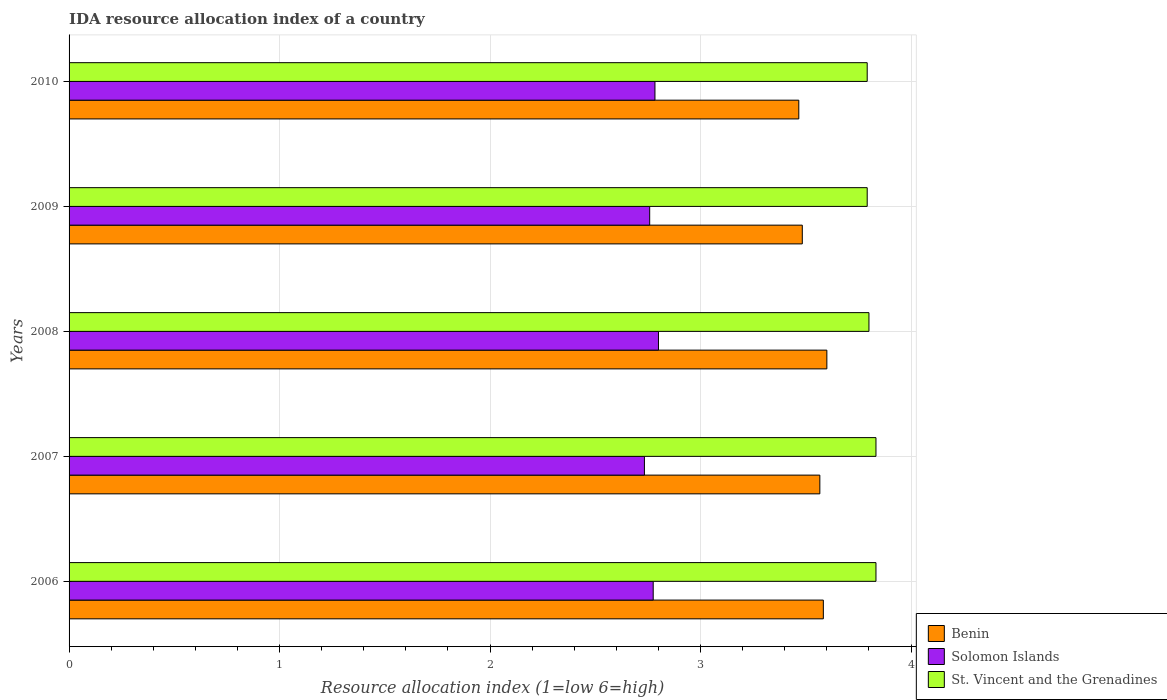How many different coloured bars are there?
Your answer should be very brief. 3. In how many cases, is the number of bars for a given year not equal to the number of legend labels?
Provide a succinct answer. 0. What is the IDA resource allocation index in Benin in 2007?
Make the answer very short. 3.57. Across all years, what is the maximum IDA resource allocation index in St. Vincent and the Grenadines?
Your response must be concise. 3.83. Across all years, what is the minimum IDA resource allocation index in Benin?
Ensure brevity in your answer.  3.47. In which year was the IDA resource allocation index in St. Vincent and the Grenadines maximum?
Provide a succinct answer. 2006. What is the total IDA resource allocation index in St. Vincent and the Grenadines in the graph?
Provide a short and direct response. 19.05. What is the difference between the IDA resource allocation index in Benin in 2010 and the IDA resource allocation index in St. Vincent and the Grenadines in 2007?
Provide a short and direct response. -0.37. What is the average IDA resource allocation index in St. Vincent and the Grenadines per year?
Provide a short and direct response. 3.81. In the year 2010, what is the difference between the IDA resource allocation index in Solomon Islands and IDA resource allocation index in Benin?
Keep it short and to the point. -0.68. In how many years, is the IDA resource allocation index in Solomon Islands greater than 3 ?
Your answer should be very brief. 0. What is the ratio of the IDA resource allocation index in Solomon Islands in 2008 to that in 2009?
Ensure brevity in your answer.  1.02. Is the IDA resource allocation index in St. Vincent and the Grenadines in 2007 less than that in 2009?
Keep it short and to the point. No. Is the difference between the IDA resource allocation index in Solomon Islands in 2006 and 2008 greater than the difference between the IDA resource allocation index in Benin in 2006 and 2008?
Provide a short and direct response. No. What is the difference between the highest and the second highest IDA resource allocation index in Solomon Islands?
Provide a succinct answer. 0.02. What is the difference between the highest and the lowest IDA resource allocation index in St. Vincent and the Grenadines?
Ensure brevity in your answer.  0.04. Is the sum of the IDA resource allocation index in Benin in 2009 and 2010 greater than the maximum IDA resource allocation index in Solomon Islands across all years?
Give a very brief answer. Yes. What does the 1st bar from the top in 2006 represents?
Offer a very short reply. St. Vincent and the Grenadines. What does the 2nd bar from the bottom in 2010 represents?
Keep it short and to the point. Solomon Islands. How many years are there in the graph?
Offer a very short reply. 5. What is the difference between two consecutive major ticks on the X-axis?
Make the answer very short. 1. Are the values on the major ticks of X-axis written in scientific E-notation?
Your answer should be very brief. No. Where does the legend appear in the graph?
Make the answer very short. Bottom right. How many legend labels are there?
Offer a very short reply. 3. What is the title of the graph?
Make the answer very short. IDA resource allocation index of a country. Does "Bangladesh" appear as one of the legend labels in the graph?
Your response must be concise. No. What is the label or title of the X-axis?
Provide a succinct answer. Resource allocation index (1=low 6=high). What is the label or title of the Y-axis?
Ensure brevity in your answer.  Years. What is the Resource allocation index (1=low 6=high) in Benin in 2006?
Offer a very short reply. 3.58. What is the Resource allocation index (1=low 6=high) of Solomon Islands in 2006?
Ensure brevity in your answer.  2.77. What is the Resource allocation index (1=low 6=high) in St. Vincent and the Grenadines in 2006?
Keep it short and to the point. 3.83. What is the Resource allocation index (1=low 6=high) in Benin in 2007?
Offer a very short reply. 3.57. What is the Resource allocation index (1=low 6=high) of Solomon Islands in 2007?
Make the answer very short. 2.73. What is the Resource allocation index (1=low 6=high) in St. Vincent and the Grenadines in 2007?
Your answer should be very brief. 3.83. What is the Resource allocation index (1=low 6=high) of Benin in 2008?
Ensure brevity in your answer.  3.6. What is the Resource allocation index (1=low 6=high) in St. Vincent and the Grenadines in 2008?
Give a very brief answer. 3.8. What is the Resource allocation index (1=low 6=high) of Benin in 2009?
Your answer should be very brief. 3.48. What is the Resource allocation index (1=low 6=high) of Solomon Islands in 2009?
Keep it short and to the point. 2.76. What is the Resource allocation index (1=low 6=high) of St. Vincent and the Grenadines in 2009?
Your answer should be very brief. 3.79. What is the Resource allocation index (1=low 6=high) of Benin in 2010?
Provide a short and direct response. 3.47. What is the Resource allocation index (1=low 6=high) of Solomon Islands in 2010?
Make the answer very short. 2.78. What is the Resource allocation index (1=low 6=high) of St. Vincent and the Grenadines in 2010?
Your answer should be compact. 3.79. Across all years, what is the maximum Resource allocation index (1=low 6=high) in St. Vincent and the Grenadines?
Ensure brevity in your answer.  3.83. Across all years, what is the minimum Resource allocation index (1=low 6=high) of Benin?
Ensure brevity in your answer.  3.47. Across all years, what is the minimum Resource allocation index (1=low 6=high) of Solomon Islands?
Ensure brevity in your answer.  2.73. Across all years, what is the minimum Resource allocation index (1=low 6=high) of St. Vincent and the Grenadines?
Offer a very short reply. 3.79. What is the total Resource allocation index (1=low 6=high) of Solomon Islands in the graph?
Keep it short and to the point. 13.85. What is the total Resource allocation index (1=low 6=high) in St. Vincent and the Grenadines in the graph?
Your response must be concise. 19.05. What is the difference between the Resource allocation index (1=low 6=high) of Benin in 2006 and that in 2007?
Make the answer very short. 0.02. What is the difference between the Resource allocation index (1=low 6=high) of Solomon Islands in 2006 and that in 2007?
Give a very brief answer. 0.04. What is the difference between the Resource allocation index (1=low 6=high) in Benin in 2006 and that in 2008?
Keep it short and to the point. -0.02. What is the difference between the Resource allocation index (1=low 6=high) in Solomon Islands in 2006 and that in 2008?
Provide a succinct answer. -0.03. What is the difference between the Resource allocation index (1=low 6=high) in Solomon Islands in 2006 and that in 2009?
Offer a very short reply. 0.02. What is the difference between the Resource allocation index (1=low 6=high) of St. Vincent and the Grenadines in 2006 and that in 2009?
Offer a terse response. 0.04. What is the difference between the Resource allocation index (1=low 6=high) of Benin in 2006 and that in 2010?
Ensure brevity in your answer.  0.12. What is the difference between the Resource allocation index (1=low 6=high) of Solomon Islands in 2006 and that in 2010?
Your response must be concise. -0.01. What is the difference between the Resource allocation index (1=low 6=high) of St. Vincent and the Grenadines in 2006 and that in 2010?
Offer a very short reply. 0.04. What is the difference between the Resource allocation index (1=low 6=high) of Benin in 2007 and that in 2008?
Offer a terse response. -0.03. What is the difference between the Resource allocation index (1=low 6=high) in Solomon Islands in 2007 and that in 2008?
Your response must be concise. -0.07. What is the difference between the Resource allocation index (1=low 6=high) of St. Vincent and the Grenadines in 2007 and that in 2008?
Give a very brief answer. 0.03. What is the difference between the Resource allocation index (1=low 6=high) of Benin in 2007 and that in 2009?
Your answer should be compact. 0.08. What is the difference between the Resource allocation index (1=low 6=high) of Solomon Islands in 2007 and that in 2009?
Your answer should be very brief. -0.03. What is the difference between the Resource allocation index (1=low 6=high) in St. Vincent and the Grenadines in 2007 and that in 2009?
Your answer should be compact. 0.04. What is the difference between the Resource allocation index (1=low 6=high) in Solomon Islands in 2007 and that in 2010?
Offer a very short reply. -0.05. What is the difference between the Resource allocation index (1=low 6=high) in St. Vincent and the Grenadines in 2007 and that in 2010?
Keep it short and to the point. 0.04. What is the difference between the Resource allocation index (1=low 6=high) of Benin in 2008 and that in 2009?
Your response must be concise. 0.12. What is the difference between the Resource allocation index (1=low 6=high) in Solomon Islands in 2008 and that in 2009?
Your answer should be very brief. 0.04. What is the difference between the Resource allocation index (1=low 6=high) of St. Vincent and the Grenadines in 2008 and that in 2009?
Keep it short and to the point. 0.01. What is the difference between the Resource allocation index (1=low 6=high) in Benin in 2008 and that in 2010?
Offer a very short reply. 0.13. What is the difference between the Resource allocation index (1=low 6=high) of Solomon Islands in 2008 and that in 2010?
Ensure brevity in your answer.  0.02. What is the difference between the Resource allocation index (1=low 6=high) of St. Vincent and the Grenadines in 2008 and that in 2010?
Keep it short and to the point. 0.01. What is the difference between the Resource allocation index (1=low 6=high) in Benin in 2009 and that in 2010?
Give a very brief answer. 0.02. What is the difference between the Resource allocation index (1=low 6=high) in Solomon Islands in 2009 and that in 2010?
Your answer should be compact. -0.03. What is the difference between the Resource allocation index (1=low 6=high) of Benin in 2006 and the Resource allocation index (1=low 6=high) of Solomon Islands in 2007?
Ensure brevity in your answer.  0.85. What is the difference between the Resource allocation index (1=low 6=high) of Benin in 2006 and the Resource allocation index (1=low 6=high) of St. Vincent and the Grenadines in 2007?
Give a very brief answer. -0.25. What is the difference between the Resource allocation index (1=low 6=high) of Solomon Islands in 2006 and the Resource allocation index (1=low 6=high) of St. Vincent and the Grenadines in 2007?
Provide a succinct answer. -1.06. What is the difference between the Resource allocation index (1=low 6=high) of Benin in 2006 and the Resource allocation index (1=low 6=high) of Solomon Islands in 2008?
Provide a short and direct response. 0.78. What is the difference between the Resource allocation index (1=low 6=high) in Benin in 2006 and the Resource allocation index (1=low 6=high) in St. Vincent and the Grenadines in 2008?
Your answer should be very brief. -0.22. What is the difference between the Resource allocation index (1=low 6=high) of Solomon Islands in 2006 and the Resource allocation index (1=low 6=high) of St. Vincent and the Grenadines in 2008?
Make the answer very short. -1.02. What is the difference between the Resource allocation index (1=low 6=high) in Benin in 2006 and the Resource allocation index (1=low 6=high) in Solomon Islands in 2009?
Provide a short and direct response. 0.82. What is the difference between the Resource allocation index (1=low 6=high) of Benin in 2006 and the Resource allocation index (1=low 6=high) of St. Vincent and the Grenadines in 2009?
Provide a succinct answer. -0.21. What is the difference between the Resource allocation index (1=low 6=high) of Solomon Islands in 2006 and the Resource allocation index (1=low 6=high) of St. Vincent and the Grenadines in 2009?
Provide a succinct answer. -1.02. What is the difference between the Resource allocation index (1=low 6=high) of Benin in 2006 and the Resource allocation index (1=low 6=high) of Solomon Islands in 2010?
Provide a short and direct response. 0.8. What is the difference between the Resource allocation index (1=low 6=high) of Benin in 2006 and the Resource allocation index (1=low 6=high) of St. Vincent and the Grenadines in 2010?
Ensure brevity in your answer.  -0.21. What is the difference between the Resource allocation index (1=low 6=high) of Solomon Islands in 2006 and the Resource allocation index (1=low 6=high) of St. Vincent and the Grenadines in 2010?
Provide a succinct answer. -1.02. What is the difference between the Resource allocation index (1=low 6=high) in Benin in 2007 and the Resource allocation index (1=low 6=high) in Solomon Islands in 2008?
Your answer should be compact. 0.77. What is the difference between the Resource allocation index (1=low 6=high) in Benin in 2007 and the Resource allocation index (1=low 6=high) in St. Vincent and the Grenadines in 2008?
Your answer should be very brief. -0.23. What is the difference between the Resource allocation index (1=low 6=high) of Solomon Islands in 2007 and the Resource allocation index (1=low 6=high) of St. Vincent and the Grenadines in 2008?
Provide a short and direct response. -1.07. What is the difference between the Resource allocation index (1=low 6=high) in Benin in 2007 and the Resource allocation index (1=low 6=high) in Solomon Islands in 2009?
Keep it short and to the point. 0.81. What is the difference between the Resource allocation index (1=low 6=high) in Benin in 2007 and the Resource allocation index (1=low 6=high) in St. Vincent and the Grenadines in 2009?
Ensure brevity in your answer.  -0.23. What is the difference between the Resource allocation index (1=low 6=high) in Solomon Islands in 2007 and the Resource allocation index (1=low 6=high) in St. Vincent and the Grenadines in 2009?
Your answer should be compact. -1.06. What is the difference between the Resource allocation index (1=low 6=high) of Benin in 2007 and the Resource allocation index (1=low 6=high) of Solomon Islands in 2010?
Make the answer very short. 0.78. What is the difference between the Resource allocation index (1=low 6=high) in Benin in 2007 and the Resource allocation index (1=low 6=high) in St. Vincent and the Grenadines in 2010?
Ensure brevity in your answer.  -0.23. What is the difference between the Resource allocation index (1=low 6=high) in Solomon Islands in 2007 and the Resource allocation index (1=low 6=high) in St. Vincent and the Grenadines in 2010?
Ensure brevity in your answer.  -1.06. What is the difference between the Resource allocation index (1=low 6=high) in Benin in 2008 and the Resource allocation index (1=low 6=high) in Solomon Islands in 2009?
Make the answer very short. 0.84. What is the difference between the Resource allocation index (1=low 6=high) in Benin in 2008 and the Resource allocation index (1=low 6=high) in St. Vincent and the Grenadines in 2009?
Your response must be concise. -0.19. What is the difference between the Resource allocation index (1=low 6=high) of Solomon Islands in 2008 and the Resource allocation index (1=low 6=high) of St. Vincent and the Grenadines in 2009?
Provide a short and direct response. -0.99. What is the difference between the Resource allocation index (1=low 6=high) of Benin in 2008 and the Resource allocation index (1=low 6=high) of Solomon Islands in 2010?
Provide a succinct answer. 0.82. What is the difference between the Resource allocation index (1=low 6=high) in Benin in 2008 and the Resource allocation index (1=low 6=high) in St. Vincent and the Grenadines in 2010?
Offer a terse response. -0.19. What is the difference between the Resource allocation index (1=low 6=high) in Solomon Islands in 2008 and the Resource allocation index (1=low 6=high) in St. Vincent and the Grenadines in 2010?
Keep it short and to the point. -0.99. What is the difference between the Resource allocation index (1=low 6=high) in Benin in 2009 and the Resource allocation index (1=low 6=high) in St. Vincent and the Grenadines in 2010?
Keep it short and to the point. -0.31. What is the difference between the Resource allocation index (1=low 6=high) in Solomon Islands in 2009 and the Resource allocation index (1=low 6=high) in St. Vincent and the Grenadines in 2010?
Offer a terse response. -1.03. What is the average Resource allocation index (1=low 6=high) in Benin per year?
Keep it short and to the point. 3.54. What is the average Resource allocation index (1=low 6=high) in Solomon Islands per year?
Offer a very short reply. 2.77. What is the average Resource allocation index (1=low 6=high) of St. Vincent and the Grenadines per year?
Provide a short and direct response. 3.81. In the year 2006, what is the difference between the Resource allocation index (1=low 6=high) in Benin and Resource allocation index (1=low 6=high) in Solomon Islands?
Provide a succinct answer. 0.81. In the year 2006, what is the difference between the Resource allocation index (1=low 6=high) of Solomon Islands and Resource allocation index (1=low 6=high) of St. Vincent and the Grenadines?
Offer a very short reply. -1.06. In the year 2007, what is the difference between the Resource allocation index (1=low 6=high) of Benin and Resource allocation index (1=low 6=high) of St. Vincent and the Grenadines?
Keep it short and to the point. -0.27. In the year 2007, what is the difference between the Resource allocation index (1=low 6=high) in Solomon Islands and Resource allocation index (1=low 6=high) in St. Vincent and the Grenadines?
Keep it short and to the point. -1.1. In the year 2008, what is the difference between the Resource allocation index (1=low 6=high) in Benin and Resource allocation index (1=low 6=high) in Solomon Islands?
Keep it short and to the point. 0.8. In the year 2008, what is the difference between the Resource allocation index (1=low 6=high) in Benin and Resource allocation index (1=low 6=high) in St. Vincent and the Grenadines?
Give a very brief answer. -0.2. In the year 2009, what is the difference between the Resource allocation index (1=low 6=high) of Benin and Resource allocation index (1=low 6=high) of Solomon Islands?
Provide a succinct answer. 0.72. In the year 2009, what is the difference between the Resource allocation index (1=low 6=high) in Benin and Resource allocation index (1=low 6=high) in St. Vincent and the Grenadines?
Your answer should be compact. -0.31. In the year 2009, what is the difference between the Resource allocation index (1=low 6=high) of Solomon Islands and Resource allocation index (1=low 6=high) of St. Vincent and the Grenadines?
Provide a short and direct response. -1.03. In the year 2010, what is the difference between the Resource allocation index (1=low 6=high) of Benin and Resource allocation index (1=low 6=high) of Solomon Islands?
Give a very brief answer. 0.68. In the year 2010, what is the difference between the Resource allocation index (1=low 6=high) in Benin and Resource allocation index (1=low 6=high) in St. Vincent and the Grenadines?
Your answer should be compact. -0.33. In the year 2010, what is the difference between the Resource allocation index (1=low 6=high) in Solomon Islands and Resource allocation index (1=low 6=high) in St. Vincent and the Grenadines?
Provide a succinct answer. -1.01. What is the ratio of the Resource allocation index (1=low 6=high) of Benin in 2006 to that in 2007?
Make the answer very short. 1. What is the ratio of the Resource allocation index (1=low 6=high) in Solomon Islands in 2006 to that in 2007?
Provide a succinct answer. 1.02. What is the ratio of the Resource allocation index (1=low 6=high) of Benin in 2006 to that in 2008?
Provide a short and direct response. 1. What is the ratio of the Resource allocation index (1=low 6=high) of St. Vincent and the Grenadines in 2006 to that in 2008?
Your answer should be compact. 1.01. What is the ratio of the Resource allocation index (1=low 6=high) in Benin in 2006 to that in 2009?
Offer a very short reply. 1.03. What is the ratio of the Resource allocation index (1=low 6=high) in Solomon Islands in 2006 to that in 2009?
Offer a very short reply. 1.01. What is the ratio of the Resource allocation index (1=low 6=high) of Benin in 2006 to that in 2010?
Ensure brevity in your answer.  1.03. What is the ratio of the Resource allocation index (1=low 6=high) in Solomon Islands in 2007 to that in 2008?
Your answer should be compact. 0.98. What is the ratio of the Resource allocation index (1=low 6=high) in St. Vincent and the Grenadines in 2007 to that in 2008?
Ensure brevity in your answer.  1.01. What is the ratio of the Resource allocation index (1=low 6=high) of Benin in 2007 to that in 2009?
Offer a very short reply. 1.02. What is the ratio of the Resource allocation index (1=low 6=high) in Solomon Islands in 2007 to that in 2009?
Your answer should be compact. 0.99. What is the ratio of the Resource allocation index (1=low 6=high) in St. Vincent and the Grenadines in 2007 to that in 2009?
Your answer should be compact. 1.01. What is the ratio of the Resource allocation index (1=low 6=high) in Benin in 2007 to that in 2010?
Offer a very short reply. 1.03. What is the ratio of the Resource allocation index (1=low 6=high) in Solomon Islands in 2007 to that in 2010?
Give a very brief answer. 0.98. What is the ratio of the Resource allocation index (1=low 6=high) of St. Vincent and the Grenadines in 2007 to that in 2010?
Your answer should be very brief. 1.01. What is the ratio of the Resource allocation index (1=low 6=high) of Benin in 2008 to that in 2009?
Offer a terse response. 1.03. What is the ratio of the Resource allocation index (1=low 6=high) of Solomon Islands in 2008 to that in 2009?
Give a very brief answer. 1.02. What is the ratio of the Resource allocation index (1=low 6=high) of St. Vincent and the Grenadines in 2008 to that in 2009?
Keep it short and to the point. 1. What is the ratio of the Resource allocation index (1=low 6=high) in Benin in 2008 to that in 2010?
Offer a terse response. 1.04. What is the ratio of the Resource allocation index (1=low 6=high) in St. Vincent and the Grenadines in 2008 to that in 2010?
Ensure brevity in your answer.  1. What is the ratio of the Resource allocation index (1=low 6=high) in St. Vincent and the Grenadines in 2009 to that in 2010?
Give a very brief answer. 1. What is the difference between the highest and the second highest Resource allocation index (1=low 6=high) of Benin?
Offer a very short reply. 0.02. What is the difference between the highest and the second highest Resource allocation index (1=low 6=high) of Solomon Islands?
Your answer should be compact. 0.02. What is the difference between the highest and the second highest Resource allocation index (1=low 6=high) of St. Vincent and the Grenadines?
Offer a very short reply. 0. What is the difference between the highest and the lowest Resource allocation index (1=low 6=high) in Benin?
Make the answer very short. 0.13. What is the difference between the highest and the lowest Resource allocation index (1=low 6=high) in Solomon Islands?
Provide a short and direct response. 0.07. What is the difference between the highest and the lowest Resource allocation index (1=low 6=high) in St. Vincent and the Grenadines?
Your response must be concise. 0.04. 